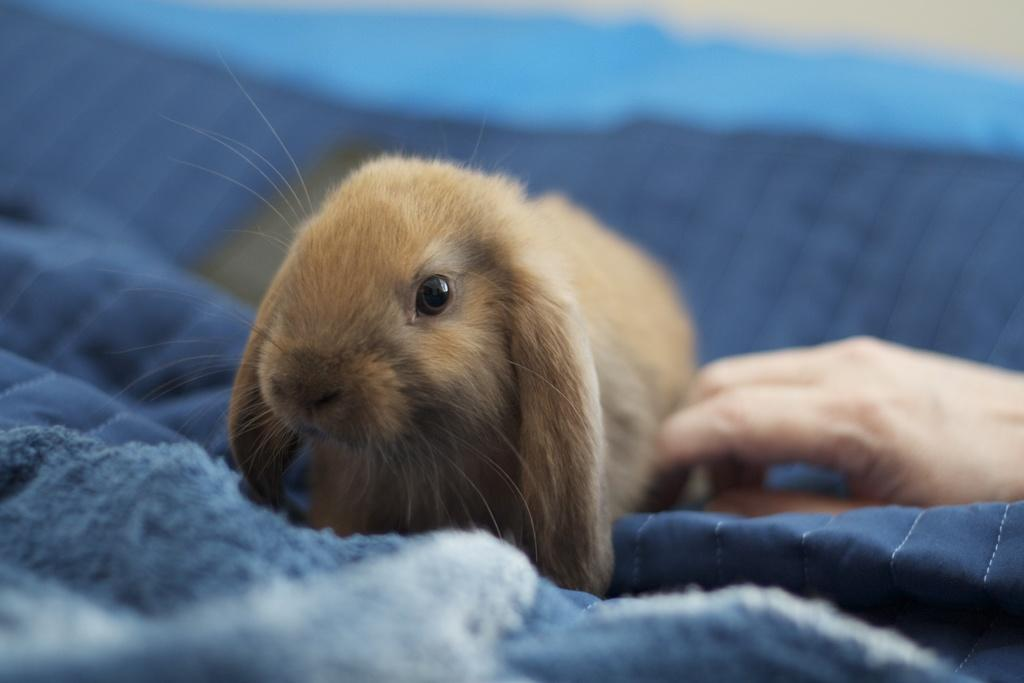What is sitting on the bed in the image? There is an animal sitting on the bed in the image. Can you describe the person on the right side of the image? The person on the right side of the image is not described in the provided facts. What color is the bed in the image? The bed has a blue color. What selection of dates is available on the calendar in the image? There is no calendar present in the image, so it is not possible to answer that question. 